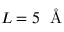Convert formula to latex. <formula><loc_0><loc_0><loc_500><loc_500>L = 5 \, \AA</formula> 